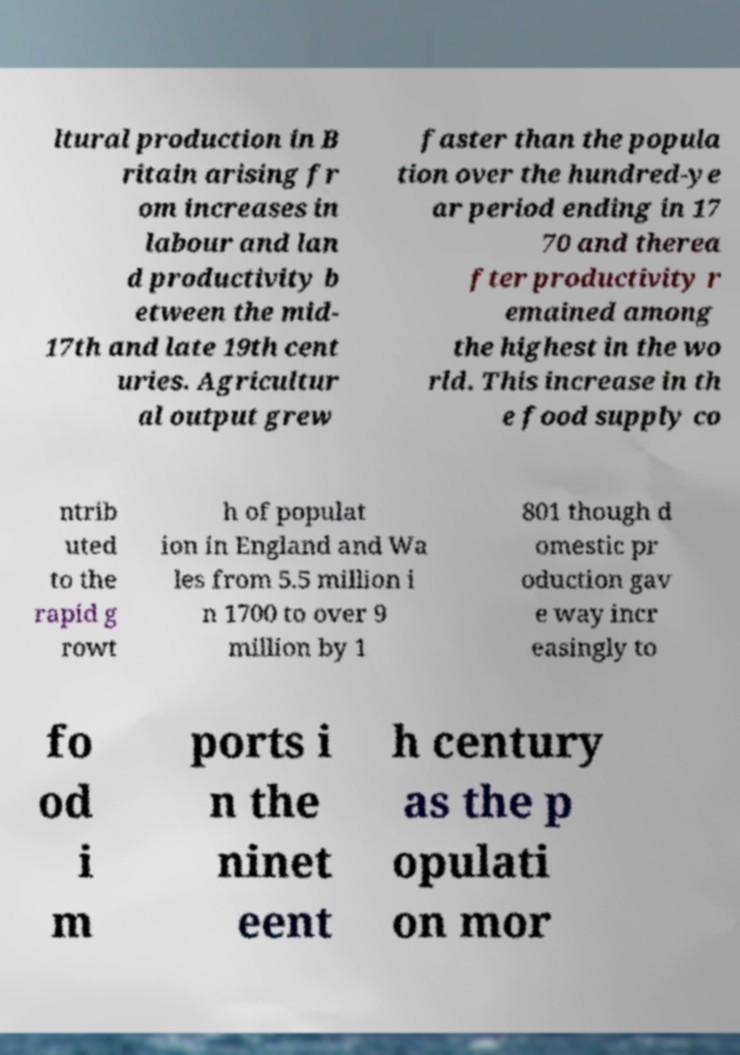Please read and relay the text visible in this image. What does it say? ltural production in B ritain arising fr om increases in labour and lan d productivity b etween the mid- 17th and late 19th cent uries. Agricultur al output grew faster than the popula tion over the hundred-ye ar period ending in 17 70 and therea fter productivity r emained among the highest in the wo rld. This increase in th e food supply co ntrib uted to the rapid g rowt h of populat ion in England and Wa les from 5.5 million i n 1700 to over 9 million by 1 801 though d omestic pr oduction gav e way incr easingly to fo od i m ports i n the ninet eent h century as the p opulati on mor 